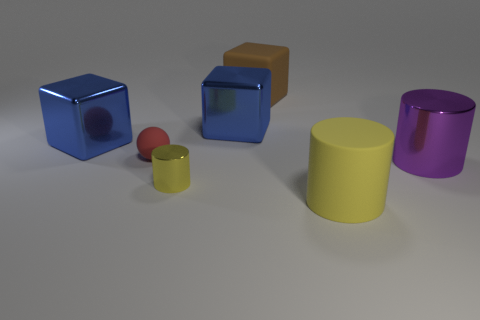Is there any other thing that has the same shape as the small matte object?
Make the answer very short. No. What is the size of the cylinder that is both behind the large rubber cylinder and on the left side of the purple object?
Make the answer very short. Small. What material is the purple cylinder that is in front of the large blue object on the left side of the metallic object that is in front of the purple object?
Your answer should be compact. Metal. What is the material of the other cylinder that is the same color as the rubber cylinder?
Offer a very short reply. Metal. There is a metal cylinder right of the big matte cylinder; is it the same color as the cylinder left of the large matte cylinder?
Ensure brevity in your answer.  No. What shape is the large rubber object in front of the metal thing in front of the shiny cylinder right of the yellow matte cylinder?
Your response must be concise. Cylinder. What is the shape of the metallic object that is on the right side of the small yellow shiny cylinder and in front of the red sphere?
Provide a succinct answer. Cylinder. There is a metal cylinder on the left side of the matte object that is right of the large matte cube; how many small balls are on the right side of it?
Offer a very short reply. 0. What is the size of the rubber thing that is the same shape as the tiny metal thing?
Keep it short and to the point. Large. Is there any other thing that has the same size as the purple shiny cylinder?
Keep it short and to the point. Yes. 